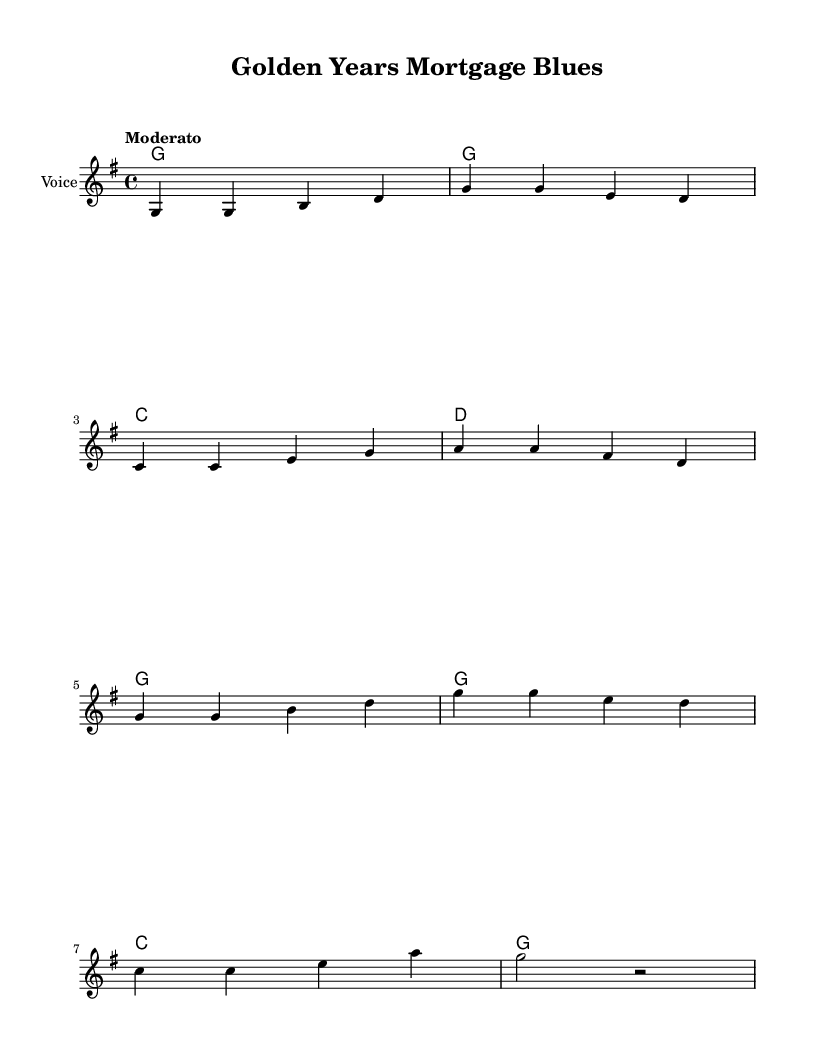What is the key signature of this music? The key signature is indicated at the beginning of the staff. Here, it shows one sharp (F#), which corresponds to G major.
Answer: G major What is the time signature of this music? The time signature is displayed at the beginning of the staff, indicating how many beats are in a measure. Here, it is 4/4, meaning there are four beats per measure.
Answer: 4/4 What is the tempo marking of this piece? The tempo is specified directly at the beginning of the score. "Moderato" indicates a moderate speed for the piece.
Answer: Moderato What is the primary chord used in the harmony? Looking at the chord progression in the harmonies section, G is the first listed chord and appears consistently throughout, indicating it is the primary chord.
Answer: G What lyrical theme does this song address? The lyrics focus on financial concerns and options for retirees, specifically addressing the need for mortgages to maintain stability in their neighborhoods.
Answer: Financial concerns 